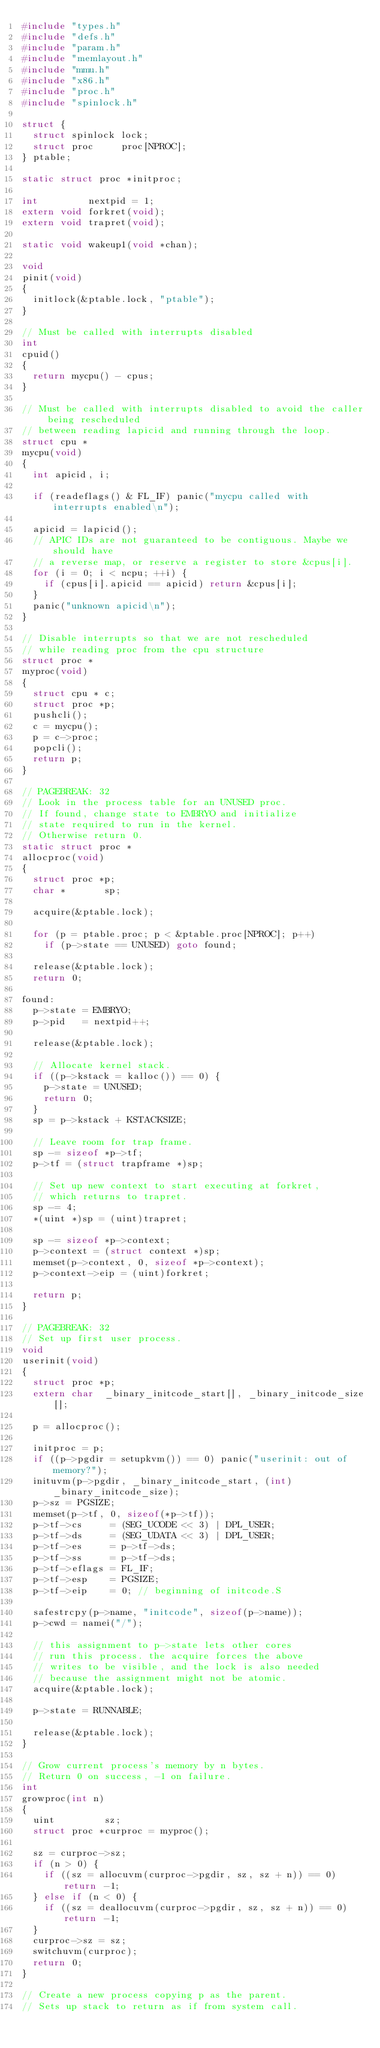Convert code to text. <code><loc_0><loc_0><loc_500><loc_500><_C_>#include "types.h"
#include "defs.h"
#include "param.h"
#include "memlayout.h"
#include "mmu.h"
#include "x86.h"
#include "proc.h"
#include "spinlock.h"

struct {
	struct spinlock lock;
	struct proc     proc[NPROC];
} ptable;

static struct proc *initproc;

int         nextpid = 1;
extern void forkret(void);
extern void trapret(void);

static void wakeup1(void *chan);

void
pinit(void)
{
	initlock(&ptable.lock, "ptable");
}

// Must be called with interrupts disabled
int
cpuid()
{
	return mycpu() - cpus;
}

// Must be called with interrupts disabled to avoid the caller being rescheduled
// between reading lapicid and running through the loop.
struct cpu *
mycpu(void)
{
	int apicid, i;

	if (readeflags() & FL_IF) panic("mycpu called with interrupts enabled\n");

	apicid = lapicid();
	// APIC IDs are not guaranteed to be contiguous. Maybe we should have
	// a reverse map, or reserve a register to store &cpus[i].
	for (i = 0; i < ncpu; ++i) {
		if (cpus[i].apicid == apicid) return &cpus[i];
	}
	panic("unknown apicid\n");
}

// Disable interrupts so that we are not rescheduled
// while reading proc from the cpu structure
struct proc *
myproc(void)
{
	struct cpu * c;
	struct proc *p;
	pushcli();
	c = mycpu();
	p = c->proc;
	popcli();
	return p;
}

// PAGEBREAK: 32
// Look in the process table for an UNUSED proc.
// If found, change state to EMBRYO and initialize
// state required to run in the kernel.
// Otherwise return 0.
static struct proc *
allocproc(void)
{
	struct proc *p;
	char *       sp;

	acquire(&ptable.lock);

	for (p = ptable.proc; p < &ptable.proc[NPROC]; p++)
		if (p->state == UNUSED) goto found;

	release(&ptable.lock);
	return 0;

found:
	p->state = EMBRYO;
	p->pid   = nextpid++;

	release(&ptable.lock);

	// Allocate kernel stack.
	if ((p->kstack = kalloc()) == 0) {
		p->state = UNUSED;
		return 0;
	}
	sp = p->kstack + KSTACKSIZE;

	// Leave room for trap frame.
	sp -= sizeof *p->tf;
	p->tf = (struct trapframe *)sp;

	// Set up new context to start executing at forkret,
	// which returns to trapret.
	sp -= 4;
	*(uint *)sp = (uint)trapret;

	sp -= sizeof *p->context;
	p->context = (struct context *)sp;
	memset(p->context, 0, sizeof *p->context);
	p->context->eip = (uint)forkret;

	return p;
}

// PAGEBREAK: 32
// Set up first user process.
void
userinit(void)
{
	struct proc *p;
	extern char  _binary_initcode_start[], _binary_initcode_size[];

	p = allocproc();

	initproc = p;
	if ((p->pgdir = setupkvm()) == 0) panic("userinit: out of memory?");
	inituvm(p->pgdir, _binary_initcode_start, (int)_binary_initcode_size);
	p->sz = PGSIZE;
	memset(p->tf, 0, sizeof(*p->tf));
	p->tf->cs     = (SEG_UCODE << 3) | DPL_USER;
	p->tf->ds     = (SEG_UDATA << 3) | DPL_USER;
	p->tf->es     = p->tf->ds;
	p->tf->ss     = p->tf->ds;
	p->tf->eflags = FL_IF;
	p->tf->esp    = PGSIZE;
	p->tf->eip    = 0; // beginning of initcode.S

	safestrcpy(p->name, "initcode", sizeof(p->name));
	p->cwd = namei("/");

	// this assignment to p->state lets other cores
	// run this process. the acquire forces the above
	// writes to be visible, and the lock is also needed
	// because the assignment might not be atomic.
	acquire(&ptable.lock);

	p->state = RUNNABLE;

	release(&ptable.lock);
}

// Grow current process's memory by n bytes.
// Return 0 on success, -1 on failure.
int
growproc(int n)
{
	uint         sz;
	struct proc *curproc = myproc();

	sz = curproc->sz;
	if (n > 0) {
		if ((sz = allocuvm(curproc->pgdir, sz, sz + n)) == 0) return -1;
	} else if (n < 0) {
		if ((sz = deallocuvm(curproc->pgdir, sz, sz + n)) == 0) return -1;
	}
	curproc->sz = sz;
	switchuvm(curproc);
	return 0;
}

// Create a new process copying p as the parent.
// Sets up stack to return as if from system call.</code> 